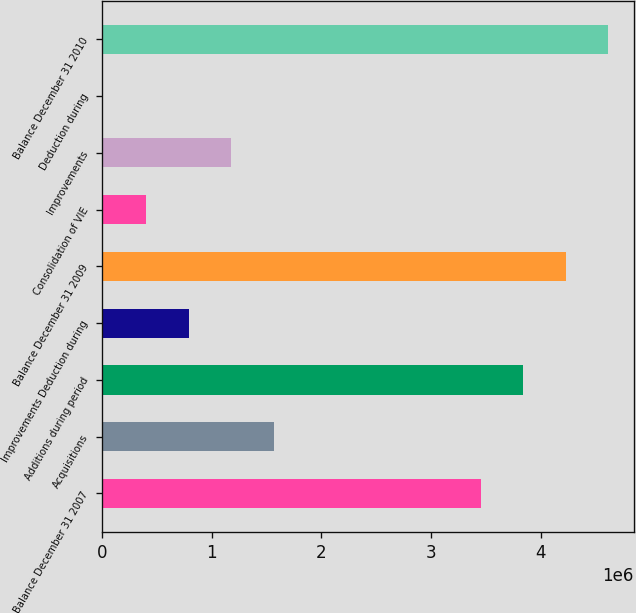<chart> <loc_0><loc_0><loc_500><loc_500><bar_chart><fcel>Balance December 31 2007<fcel>Acquisitions<fcel>Additions during period<fcel>Improvements Deduction during<fcel>Balance December 31 2009<fcel>Consolidation of VIE<fcel>Improvements<fcel>Deduction during<fcel>Balance December 31 2010<nl><fcel>3.45285e+06<fcel>1.56653e+06<fcel>3.84108e+06<fcel>790058<fcel>4.22932e+06<fcel>401822<fcel>1.17829e+06<fcel>13587<fcel>4.61755e+06<nl></chart> 